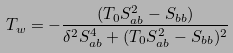Convert formula to latex. <formula><loc_0><loc_0><loc_500><loc_500>T _ { w } = - \frac { ( T _ { 0 } S _ { a b } ^ { 2 } - S _ { b b } ) } { \delta ^ { 2 } S _ { a b } ^ { 4 } + ( T _ { 0 } S _ { a b } ^ { 2 } - S _ { b b } ) ^ { 2 } }</formula> 